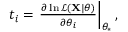<formula> <loc_0><loc_0><loc_500><loc_500>\begin{array} { r } { t _ { i } = \frac { \partial \ln \mathcal { L } ( X | \theta ) } { \partial \theta _ { i } } \right | _ { \theta _ { * } } , } \end{array}</formula> 